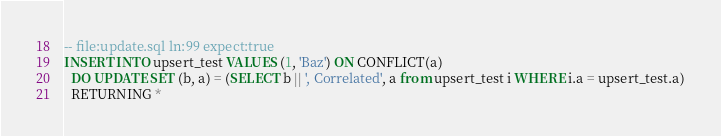<code> <loc_0><loc_0><loc_500><loc_500><_SQL_>-- file:update.sql ln:99 expect:true
INSERT INTO upsert_test VALUES (1, 'Baz') ON CONFLICT(a)
  DO UPDATE SET (b, a) = (SELECT b || ', Correlated', a from upsert_test i WHERE i.a = upsert_test.a)
  RETURNING *
</code> 